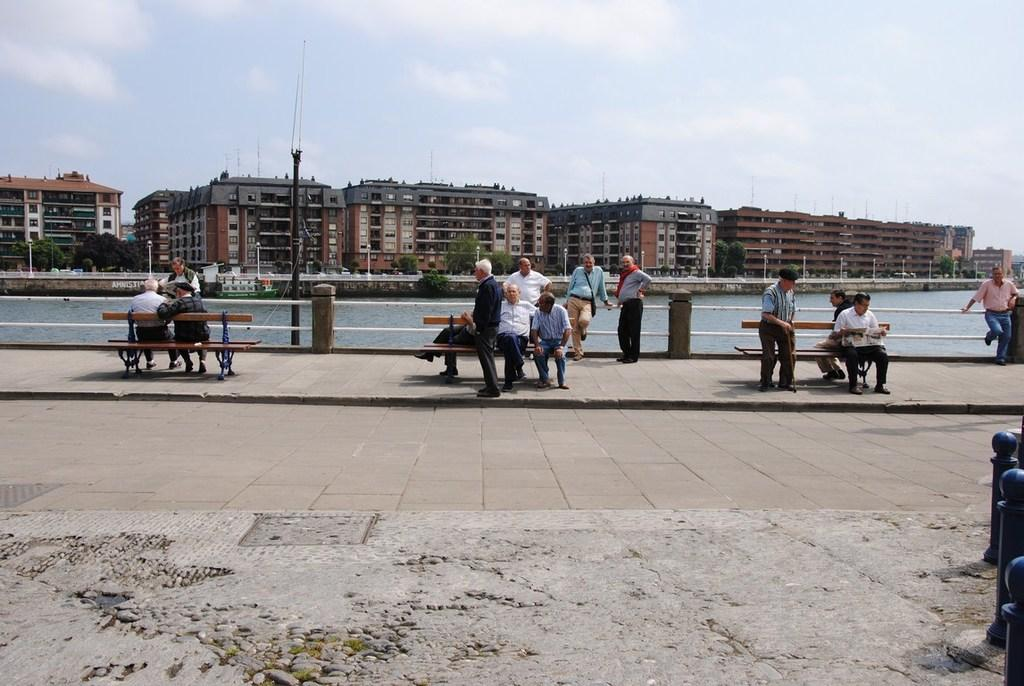What are the people in the image doing? There are people sitting on a bench and standing in the image. What can be seen in the background of the image? There is a lake visible in the image, and there are buildings beside the lake. What type of wound can be seen on the person standing near the lake? There is no wound visible on any person in the image. What ornament is hanging from the tree near the lake? There is no ornament mentioned or visible in the image. 